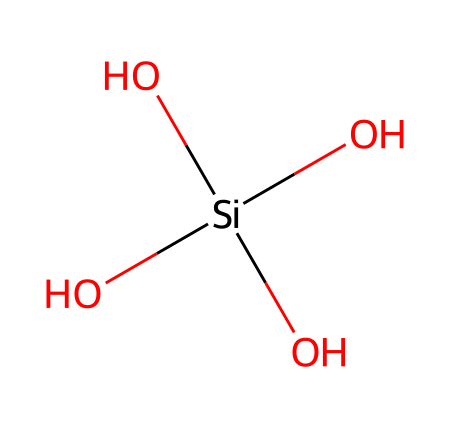What is the molecular formula for this chemical? The SMILES representation shows silicon (Si) at the center surrounded by four oxygen (O) atoms. This indicates a molecular structure with one silicon atom and four oxygen atoms, leading to the formula SiO4.
Answer: SiO4 How many silicon atoms are present in this structure? The SMILES representation indicates there is one silicon atom (Si) in the structure. This is evident as Si is mentioned only once.
Answer: 1 How many oxygen atoms are present in this structure? By analyzing the SMILES representation, there are four oxygen atoms (O) indicated, as O appears four times attached to silicon.
Answer: 4 What type of bonding is present in this compound? The structure shows silicon bonded to four oxygen atoms, which suggests covalent bonding due to the sharing of electrons between Si and O.
Answer: covalent What is the significance of the structure of this chemical in ceramic glazes? The tetrahedral arrangement of the SiO4 units in ceramics plays a crucial role in the formation of a glassy phase, influencing melt flow and adhesion in ceramic glazes.
Answer: tetrahedral arrangement How does the presence of silica affect the durability of ceramic glazes? Silica contributes to the strength and durability of ceramic glazes by forming a network structure that enhances resistance to thermal shock and mechanical stress.
Answer: enhances strength 